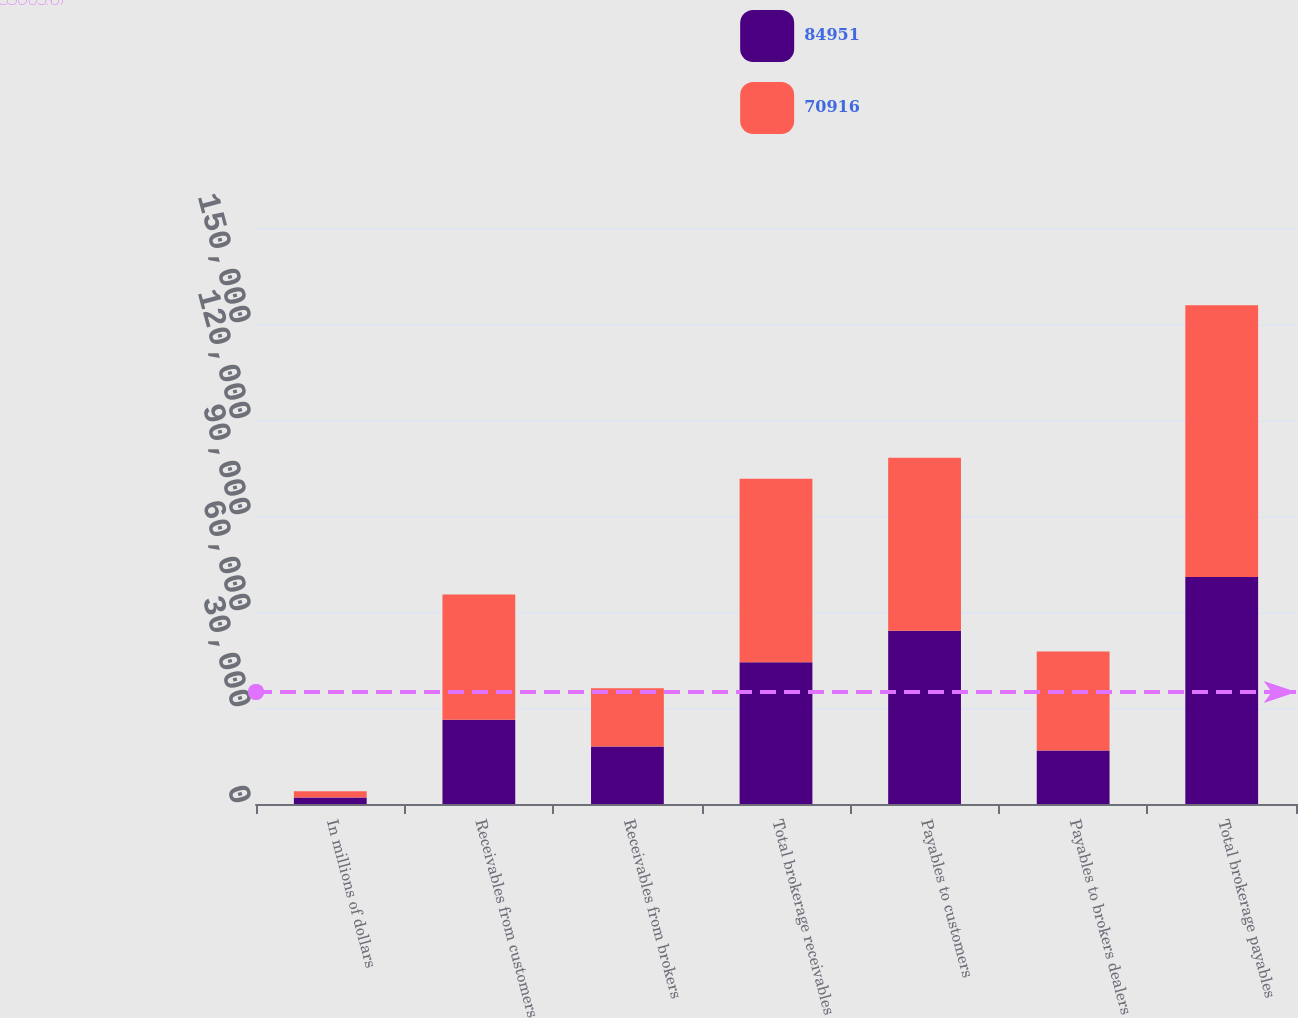Convert chart. <chart><loc_0><loc_0><loc_500><loc_500><stacked_bar_chart><ecel><fcel>In millions of dollars<fcel>Receivables from customers<fcel>Receivables from brokers<fcel>Total brokerage receivables<fcel>Payables to customers<fcel>Payables to brokers dealers<fcel>Total brokerage payables<nl><fcel>84951<fcel>2008<fcel>26297<fcel>17981<fcel>44278<fcel>54167<fcel>16749<fcel>70916<nl><fcel>70916<fcel>2007<fcel>39137<fcel>18222<fcel>57359<fcel>54038<fcel>30913<fcel>84951<nl></chart> 